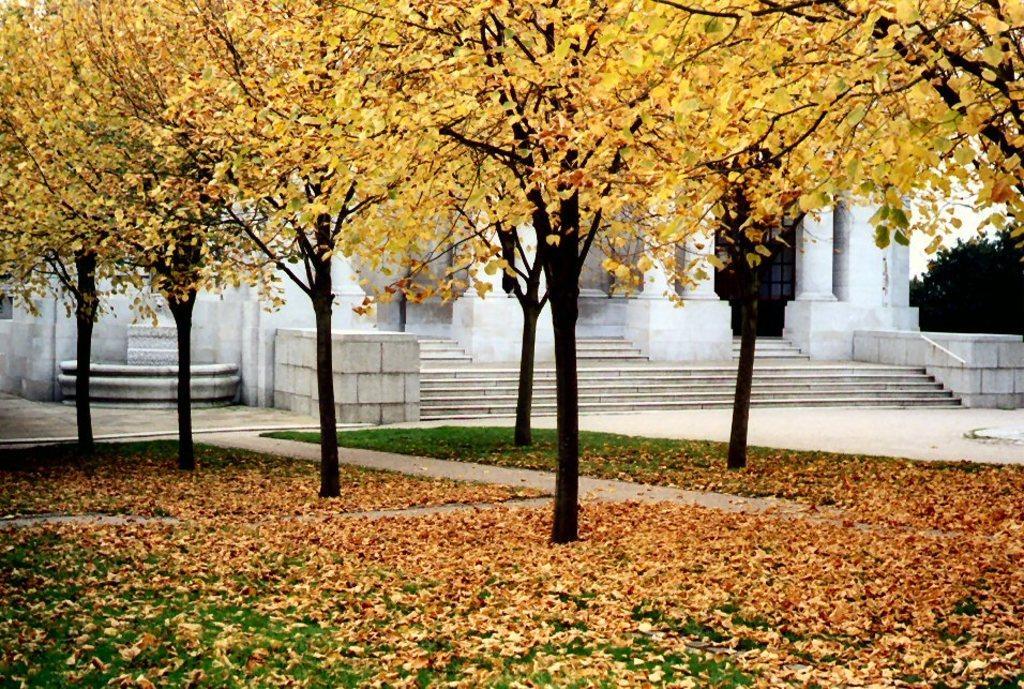Describe this image in one or two sentences. In this image I can see few leaves in yellow color. In the background I can see the building in white color and the sky is in white color. 